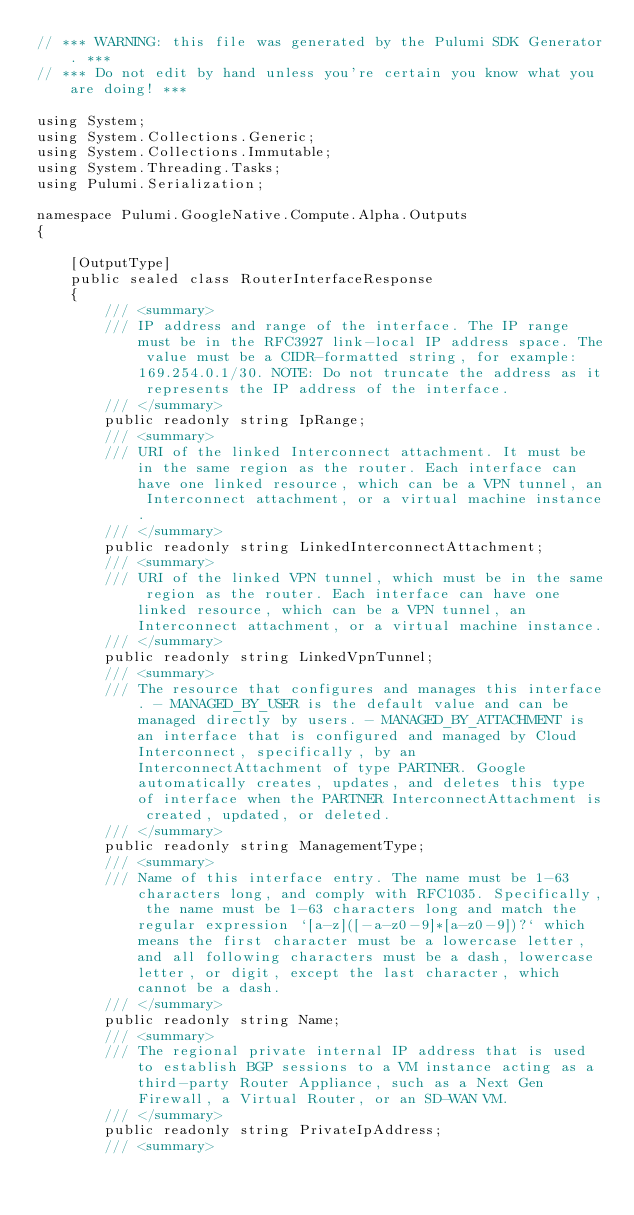<code> <loc_0><loc_0><loc_500><loc_500><_C#_>// *** WARNING: this file was generated by the Pulumi SDK Generator. ***
// *** Do not edit by hand unless you're certain you know what you are doing! ***

using System;
using System.Collections.Generic;
using System.Collections.Immutable;
using System.Threading.Tasks;
using Pulumi.Serialization;

namespace Pulumi.GoogleNative.Compute.Alpha.Outputs
{

    [OutputType]
    public sealed class RouterInterfaceResponse
    {
        /// <summary>
        /// IP address and range of the interface. The IP range must be in the RFC3927 link-local IP address space. The value must be a CIDR-formatted string, for example: 169.254.0.1/30. NOTE: Do not truncate the address as it represents the IP address of the interface.
        /// </summary>
        public readonly string IpRange;
        /// <summary>
        /// URI of the linked Interconnect attachment. It must be in the same region as the router. Each interface can have one linked resource, which can be a VPN tunnel, an Interconnect attachment, or a virtual machine instance.
        /// </summary>
        public readonly string LinkedInterconnectAttachment;
        /// <summary>
        /// URI of the linked VPN tunnel, which must be in the same region as the router. Each interface can have one linked resource, which can be a VPN tunnel, an Interconnect attachment, or a virtual machine instance.
        /// </summary>
        public readonly string LinkedVpnTunnel;
        /// <summary>
        /// The resource that configures and manages this interface. - MANAGED_BY_USER is the default value and can be managed directly by users. - MANAGED_BY_ATTACHMENT is an interface that is configured and managed by Cloud Interconnect, specifically, by an InterconnectAttachment of type PARTNER. Google automatically creates, updates, and deletes this type of interface when the PARTNER InterconnectAttachment is created, updated, or deleted. 
        /// </summary>
        public readonly string ManagementType;
        /// <summary>
        /// Name of this interface entry. The name must be 1-63 characters long, and comply with RFC1035. Specifically, the name must be 1-63 characters long and match the regular expression `[a-z]([-a-z0-9]*[a-z0-9])?` which means the first character must be a lowercase letter, and all following characters must be a dash, lowercase letter, or digit, except the last character, which cannot be a dash.
        /// </summary>
        public readonly string Name;
        /// <summary>
        /// The regional private internal IP address that is used to establish BGP sessions to a VM instance acting as a third-party Router Appliance, such as a Next Gen Firewall, a Virtual Router, or an SD-WAN VM.
        /// </summary>
        public readonly string PrivateIpAddress;
        /// <summary></code> 